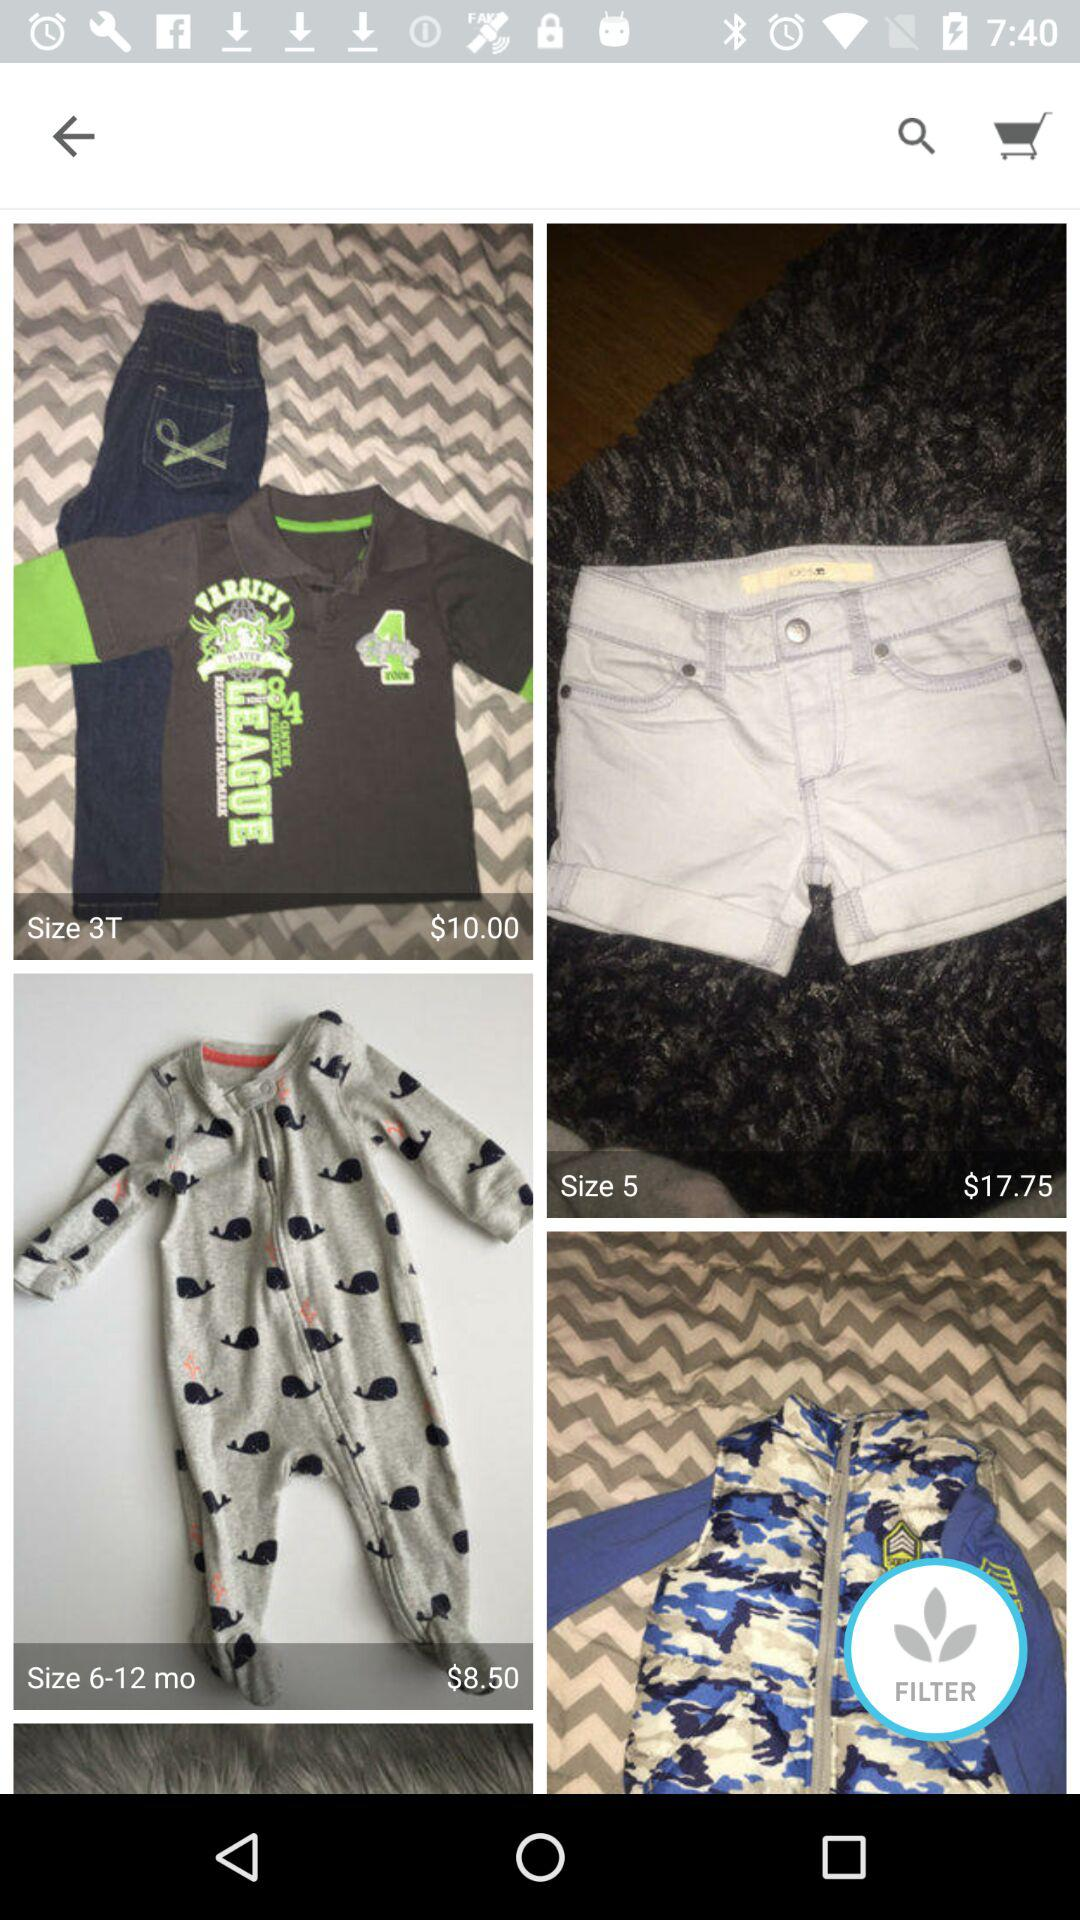What is the price of "Size 3T" clothes? The price is $10.00. 